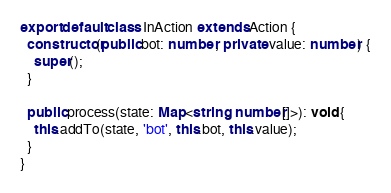Convert code to text. <code><loc_0><loc_0><loc_500><loc_500><_TypeScript_>
export default class InAction extends Action {
  constructor(public bot: number, private value: number) {
    super();
  }

  public process(state: Map<string, number[]>): void {
    this.addTo(state, 'bot', this.bot, this.value);
  }
}
</code> 